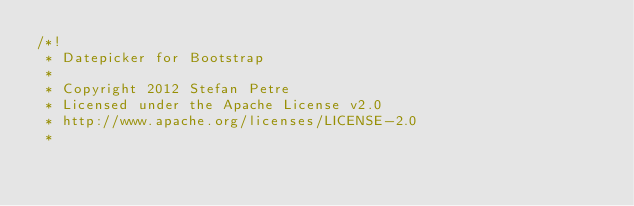<code> <loc_0><loc_0><loc_500><loc_500><_CSS_>/*!
 * Datepicker for Bootstrap
 *
 * Copyright 2012 Stefan Petre
 * Licensed under the Apache License v2.0
 * http://www.apache.org/licenses/LICENSE-2.0
 *</code> 